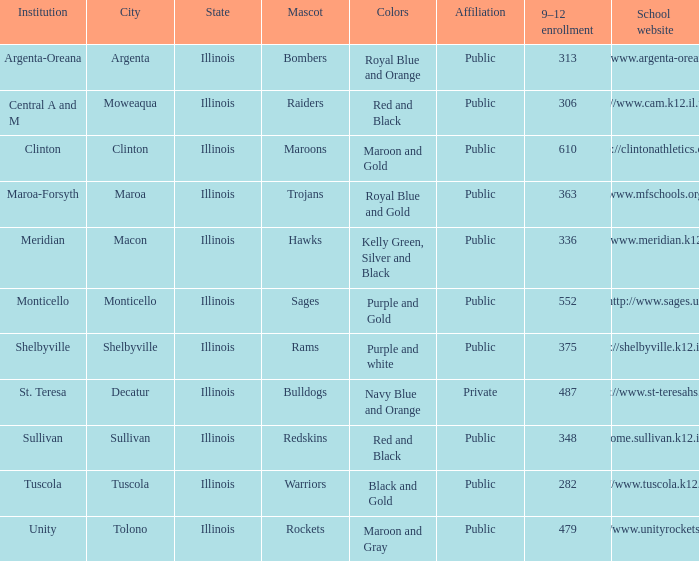What's the name of the city or town of the school that operates the http://www.mfschools.org/high/ website? Maroa-Forsyth. 